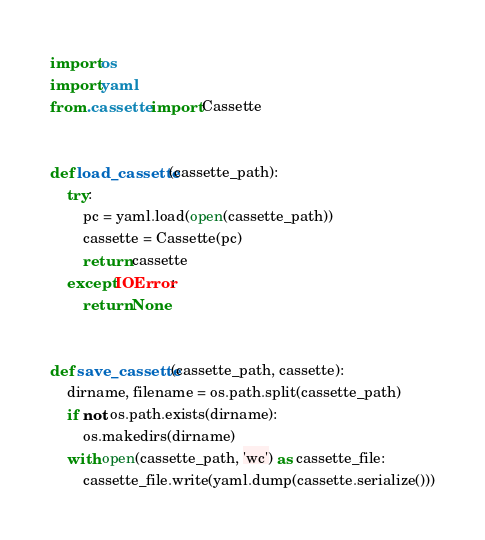<code> <loc_0><loc_0><loc_500><loc_500><_Python_>import os
import yaml
from .cassette import Cassette


def load_cassette(cassette_path):
    try:
        pc = yaml.load(open(cassette_path))
        cassette = Cassette(pc)
        return cassette
    except IOError:
        return None


def save_cassette(cassette_path, cassette):
    dirname, filename = os.path.split(cassette_path)
    if not os.path.exists(dirname):
        os.makedirs(dirname)
    with open(cassette_path, 'wc') as cassette_file:
        cassette_file.write(yaml.dump(cassette.serialize()))
</code> 